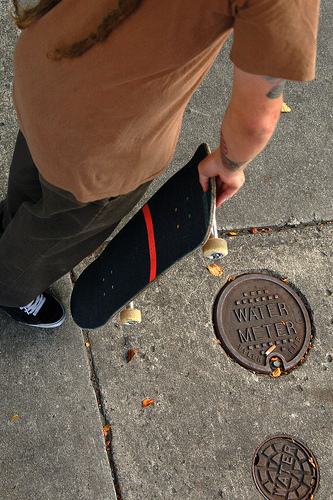<image>
Is there a skateboard on the sidewalk? No. The skateboard is not positioned on the sidewalk. They may be near each other, but the skateboard is not supported by or resting on top of the sidewalk. 